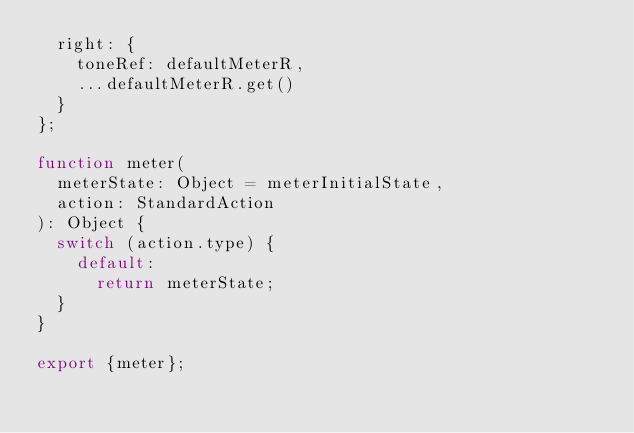Convert code to text. <code><loc_0><loc_0><loc_500><loc_500><_JavaScript_>  right: {
    toneRef: defaultMeterR,
    ...defaultMeterR.get()
  }
};

function meter(
  meterState: Object = meterInitialState,
  action: StandardAction
): Object {
  switch (action.type) {
    default:
      return meterState;
  }
}

export {meter};
</code> 